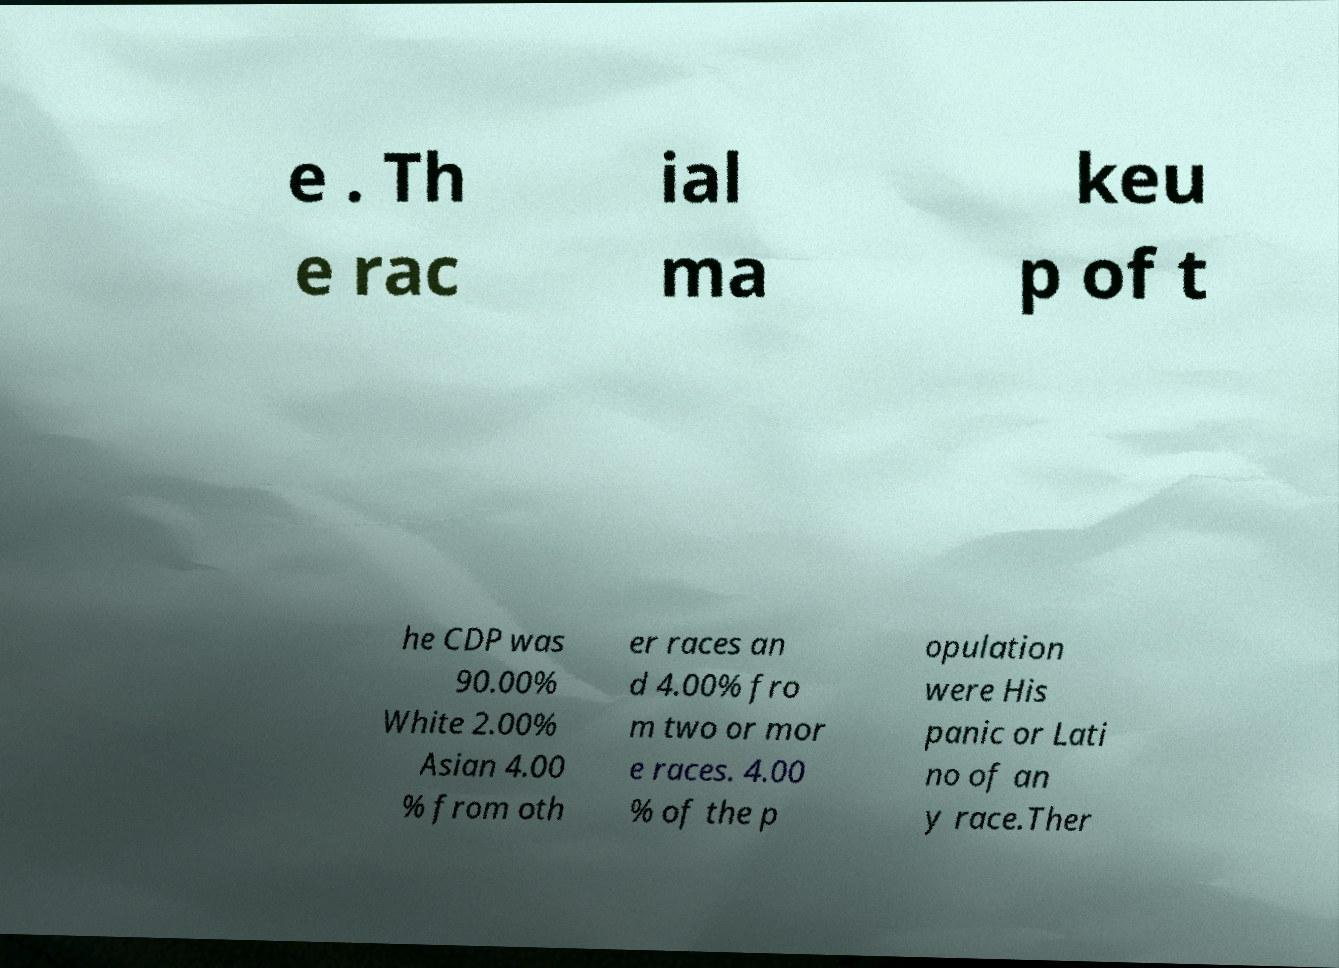Can you read and provide the text displayed in the image?This photo seems to have some interesting text. Can you extract and type it out for me? e . Th e rac ial ma keu p of t he CDP was 90.00% White 2.00% Asian 4.00 % from oth er races an d 4.00% fro m two or mor e races. 4.00 % of the p opulation were His panic or Lati no of an y race.Ther 